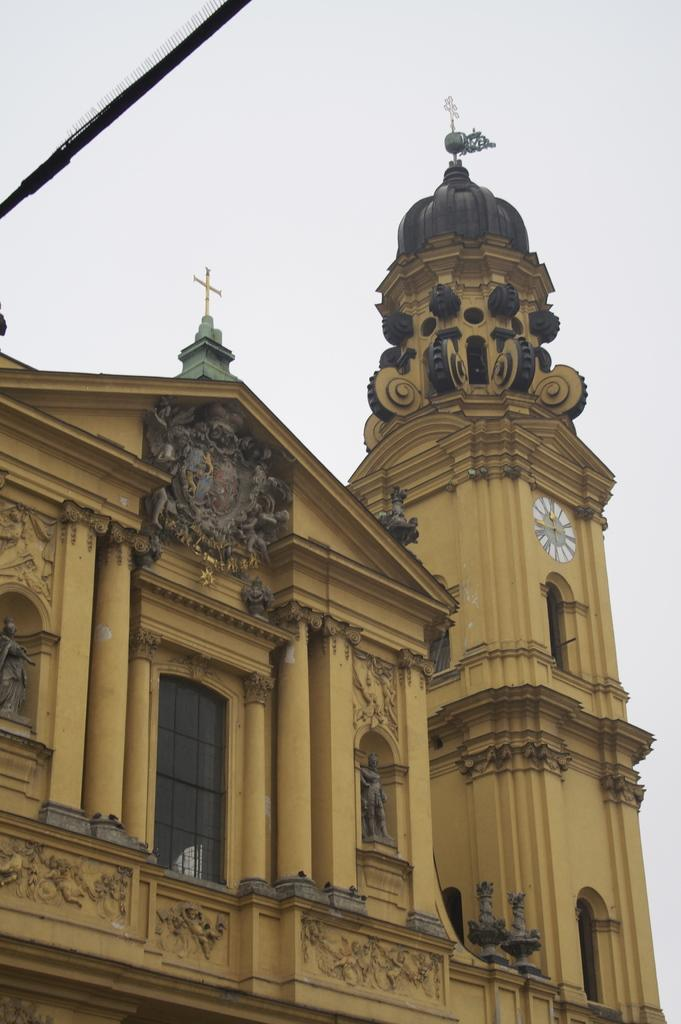What type of structure is present in the image? There is a building in the image. What specific feature can be seen on the building? There is a clock tower in the image. What colors are used for the clock tower? The clock tower is in brown and black color. What is visible in the background of the image? The sky is visible in the image. What is the color of the sky in the image? The sky is white in the image. How does the rat move around the clock tower in the image? There is no rat present in the image, so it cannot be determined how a rat would move around the clock tower. 